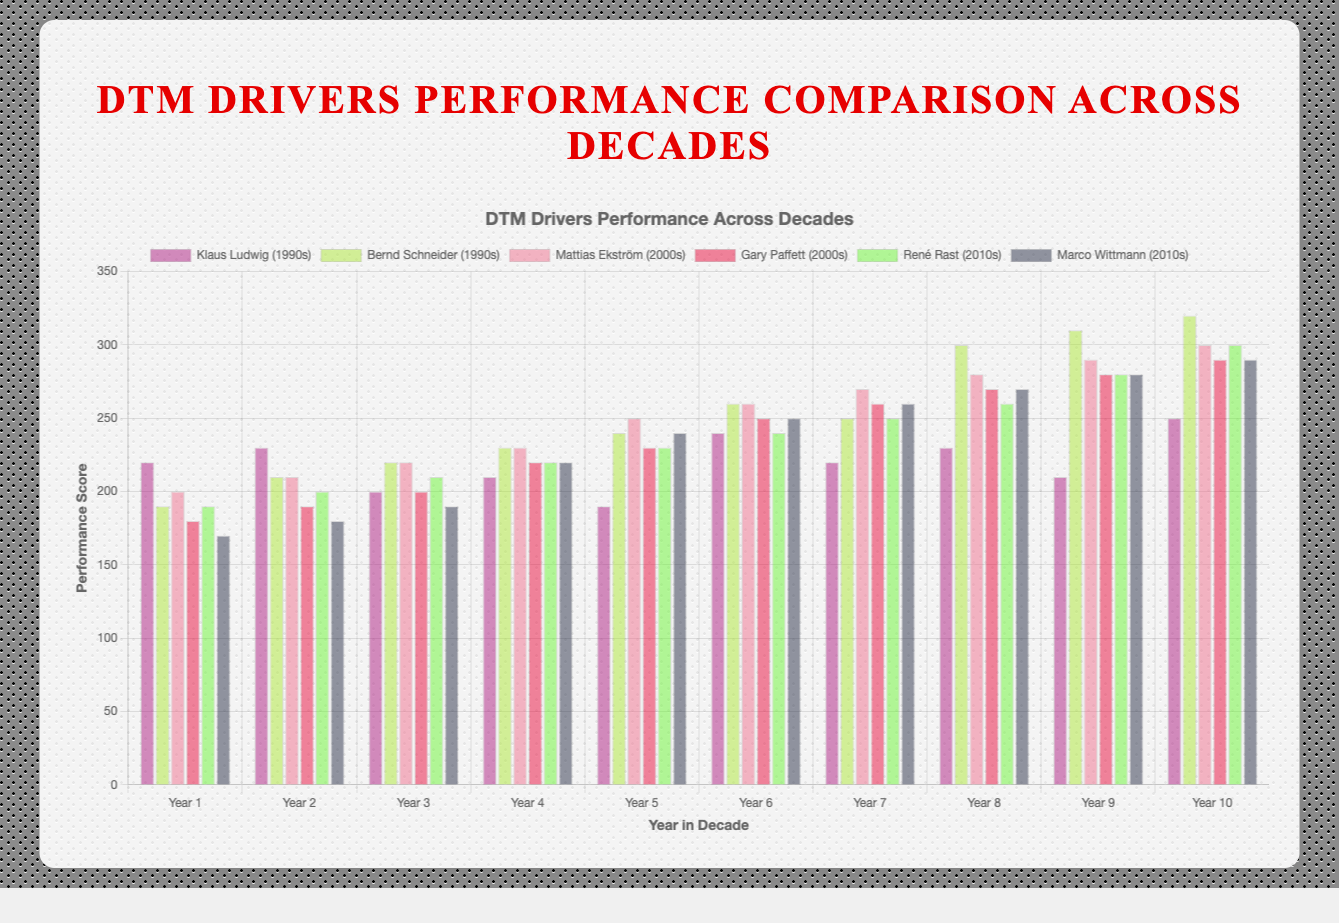Which driver had the highest performance score in the 1990s? Bernd Schneider had the highest performance score in 1999 with a score of 320. This can be seen by looking at the highest bar among the drivers in that decade.
Answer: Bernd Schneider What is the average performance score of Mattias Ekström in the 2000s? To find the average, sum all the yearly performance scores and divide by the number of years: (200 + 210 + 220 + 230 + 250 + 260 + 270 + 280 + 290 + 300) / 10 = 2510 / 10.
Answer: 251 Is Gary Paffett's performance in 2004 greater than Klaus Ludwig's performance in 1995? Gary Paffett's performance in 2004 is 230 while Klaus Ludwig's performance in 1995 is 240. By comparing the two values, we can see that 230 is less than 240.
Answer: No Which driver in the 2010s had a higher overall performance across the decade: René Rast or Marco Wittmann? To compare overall performance, sum up each driver's yearly performances:
René Rast: (190 + 200 + 210 + 220 + 230 + 240 + 250 + 260 + 280 + 300) = 2380
Marco Wittmann: (170 + 180 + 190 + 220 + 240 + 250 + 260 + 270 + 280 + 290) = 2350. René Rast's total performance is higher.
Answer: René Rast What is the difference in performance score between Bernd Schneider and Klaus Ludwig in 1999? Bernd Schneider's score in 1999 is 320, and Klaus Ludwig's score in the same year is 250. The difference is calculated as 320 - 250.
Answer: 70 Which year did Marco Wittmann and René Rast have the same performance score? By visually checking the bars for each year, we see that Marco Wittmann and René Rast both had a performance score of 220 in 2013.
Answer: 2013 What is the median performance score for Gary Paffett in the 2000s? To find the median, first list the scores in ascending order: 180, 190, 200, 220, 230, 250, 260, 270, 280, 290. The median is the average of the 5th and 6th scores: (230+250)/2 = 240.
Answer: 240 Which driver had the most consistent performance (i.e., least variation) in the 2000s? Consistency can be determined by checking the range (max - min). For Mattias Ekström: 300 - 200 = 100. For Gary Paffett: 290 - 180 = 110. Mattias Ekström has a smaller range of scores indicating more consistency.
Answer: Mattias Ekström How many drivers had a performance score above 300 in any year throughout the whole visualization? By checking all performance scores across the decades, Bernd Schneider (1997-1999), Mattias Ekström (2009), and René Rast (2019) had scores above 300. This gives us a total of three drivers.
Answer: 3 